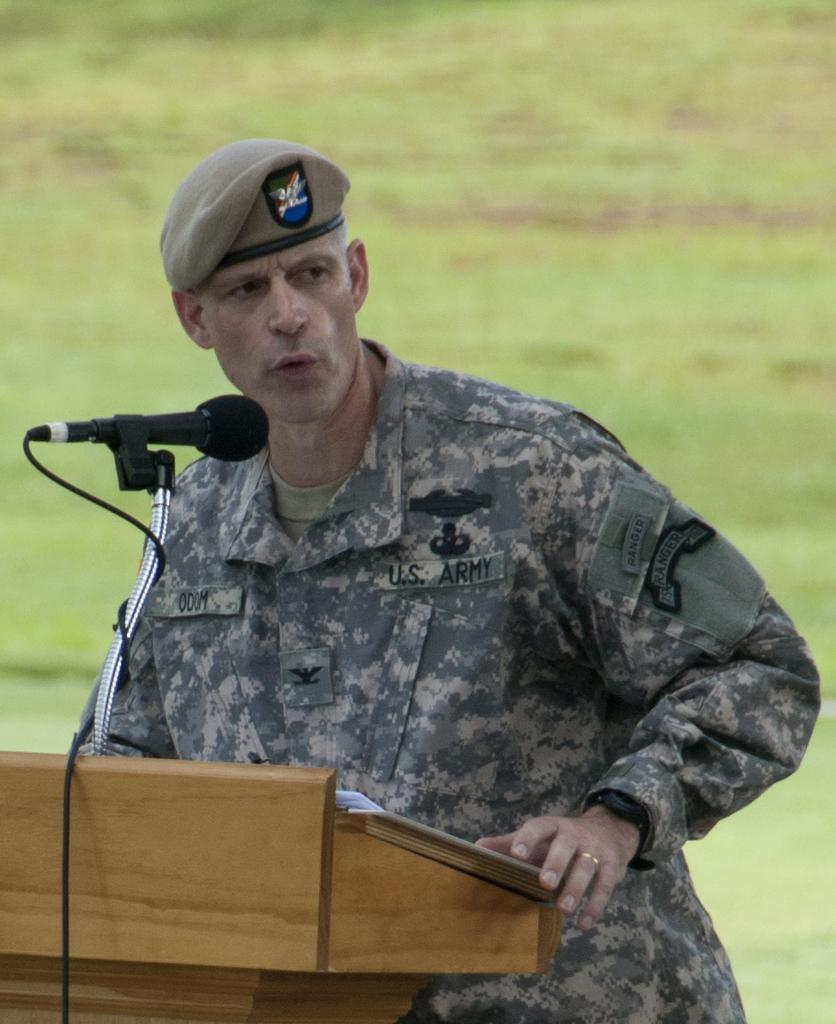Who is present in the image? There is a man in the image. What object can be seen in front of the man? There is a podium in the image. What device is used for amplifying the man's voice? There is a microphone (mike) in the image. What color is the background of the image? The background of the image is green. What type of addition problem is the man solving on the podium? There is no addition problem or any indication of mathematical activity in the image. 